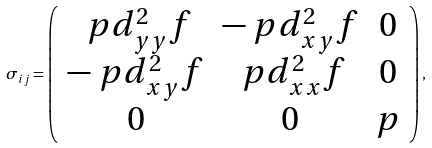Convert formula to latex. <formula><loc_0><loc_0><loc_500><loc_500>\sigma _ { i j } = \left ( \begin{array} { c c c } \ p d ^ { 2 } _ { y y } f & - \ p d ^ { 2 } _ { x y } f & 0 \\ - \ p d ^ { 2 } _ { x y } f & \ p d ^ { 2 } _ { x x } f & 0 \\ 0 & 0 & p \end{array} \right ) ,</formula> 